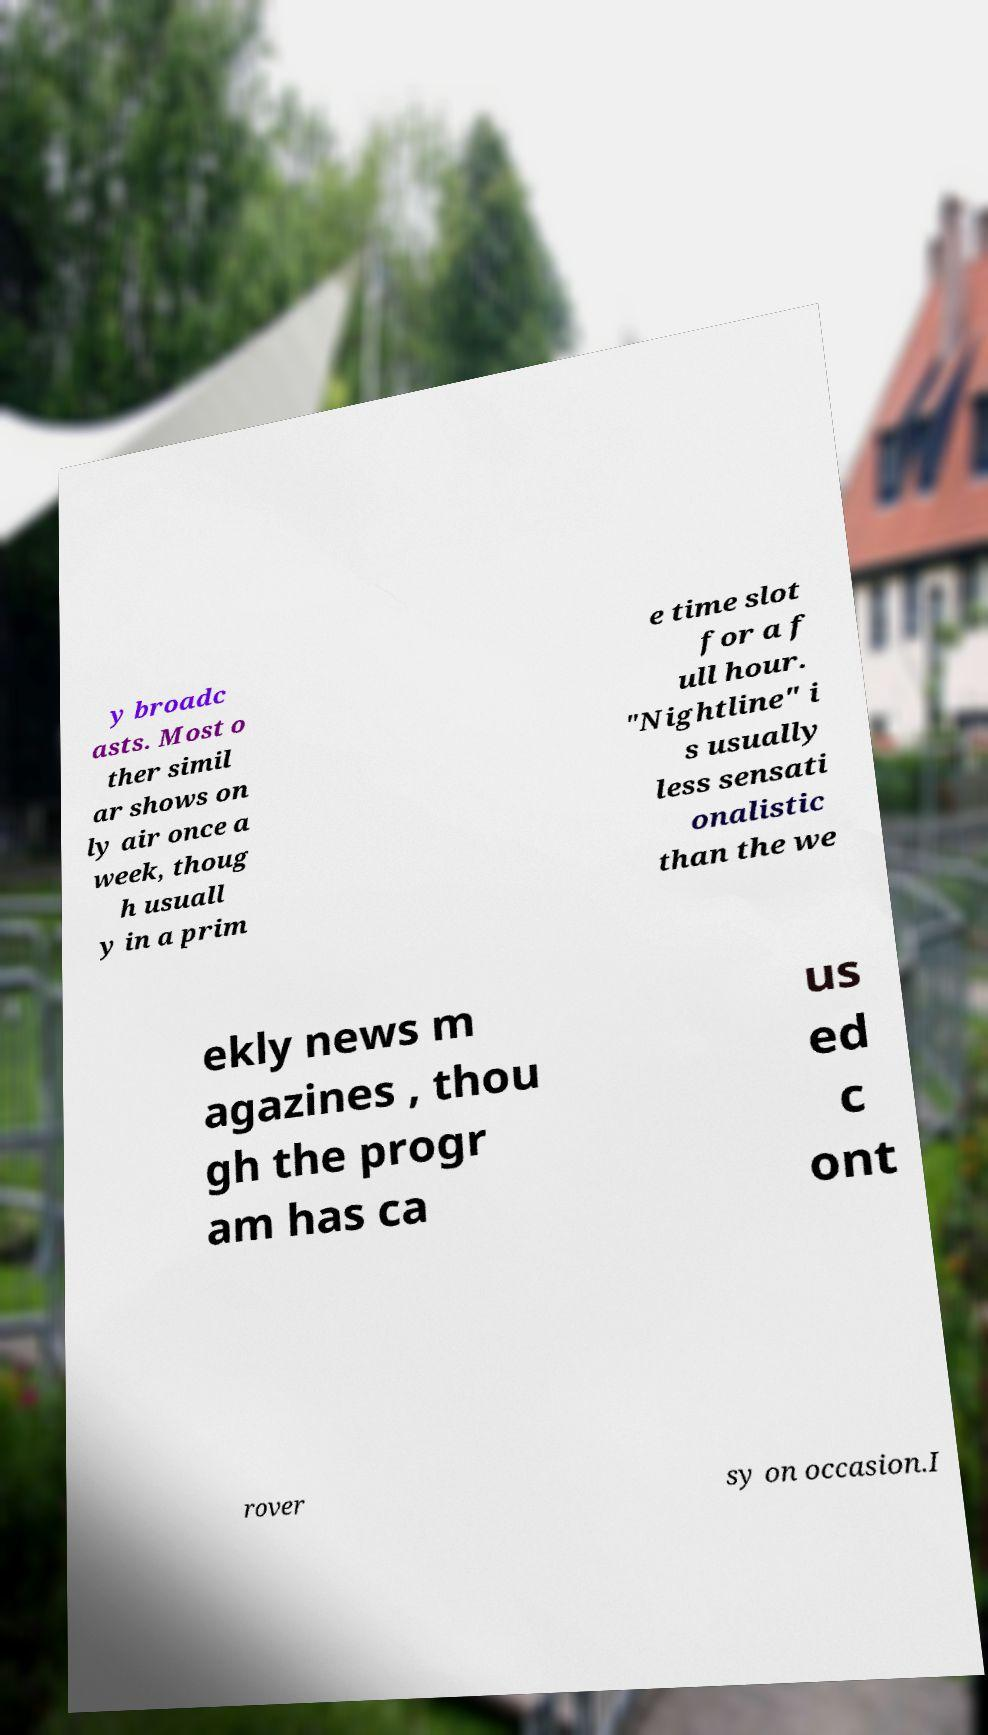Please read and relay the text visible in this image. What does it say? y broadc asts. Most o ther simil ar shows on ly air once a week, thoug h usuall y in a prim e time slot for a f ull hour. "Nightline" i s usually less sensati onalistic than the we ekly news m agazines , thou gh the progr am has ca us ed c ont rover sy on occasion.I 